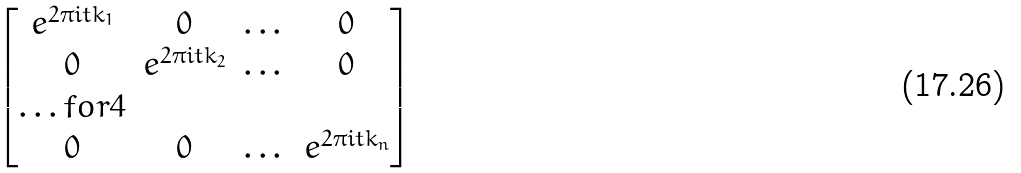Convert formula to latex. <formula><loc_0><loc_0><loc_500><loc_500>\begin{bmatrix} e ^ { 2 \pi i t k _ { 1 } } & 0 & \dots & 0 \\ 0 & e ^ { 2 \pi i t k _ { 2 } } & \dots & 0 \\ \hdots f o r { 4 } \\ 0 & 0 & \dots & e ^ { 2 \pi i t k _ { n } } \end{bmatrix}</formula> 